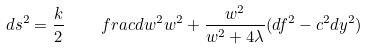Convert formula to latex. <formula><loc_0><loc_0><loc_500><loc_500>d s ^ { 2 } = \frac { k } { 2 } \quad f r a c { d w ^ { 2 } } { w ^ { 2 } } + \frac { w ^ { 2 } } { w ^ { 2 } + 4 \lambda } ( d f ^ { 2 } - c ^ { 2 } d y ^ { 2 } )</formula> 